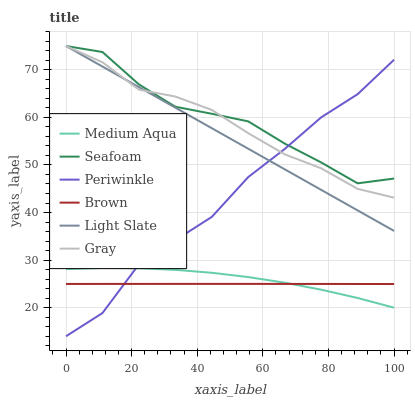Does Brown have the minimum area under the curve?
Answer yes or no. Yes. Does Seafoam have the maximum area under the curve?
Answer yes or no. Yes. Does Light Slate have the minimum area under the curve?
Answer yes or no. No. Does Light Slate have the maximum area under the curve?
Answer yes or no. No. Is Light Slate the smoothest?
Answer yes or no. Yes. Is Periwinkle the roughest?
Answer yes or no. Yes. Is Brown the smoothest?
Answer yes or no. No. Is Brown the roughest?
Answer yes or no. No. Does Brown have the lowest value?
Answer yes or no. No. Does Seafoam have the highest value?
Answer yes or no. Yes. Does Brown have the highest value?
Answer yes or no. No. Is Medium Aqua less than Seafoam?
Answer yes or no. Yes. Is Seafoam greater than Brown?
Answer yes or no. Yes. Does Periwinkle intersect Medium Aqua?
Answer yes or no. Yes. Is Periwinkle less than Medium Aqua?
Answer yes or no. No. Is Periwinkle greater than Medium Aqua?
Answer yes or no. No. Does Medium Aqua intersect Seafoam?
Answer yes or no. No. 